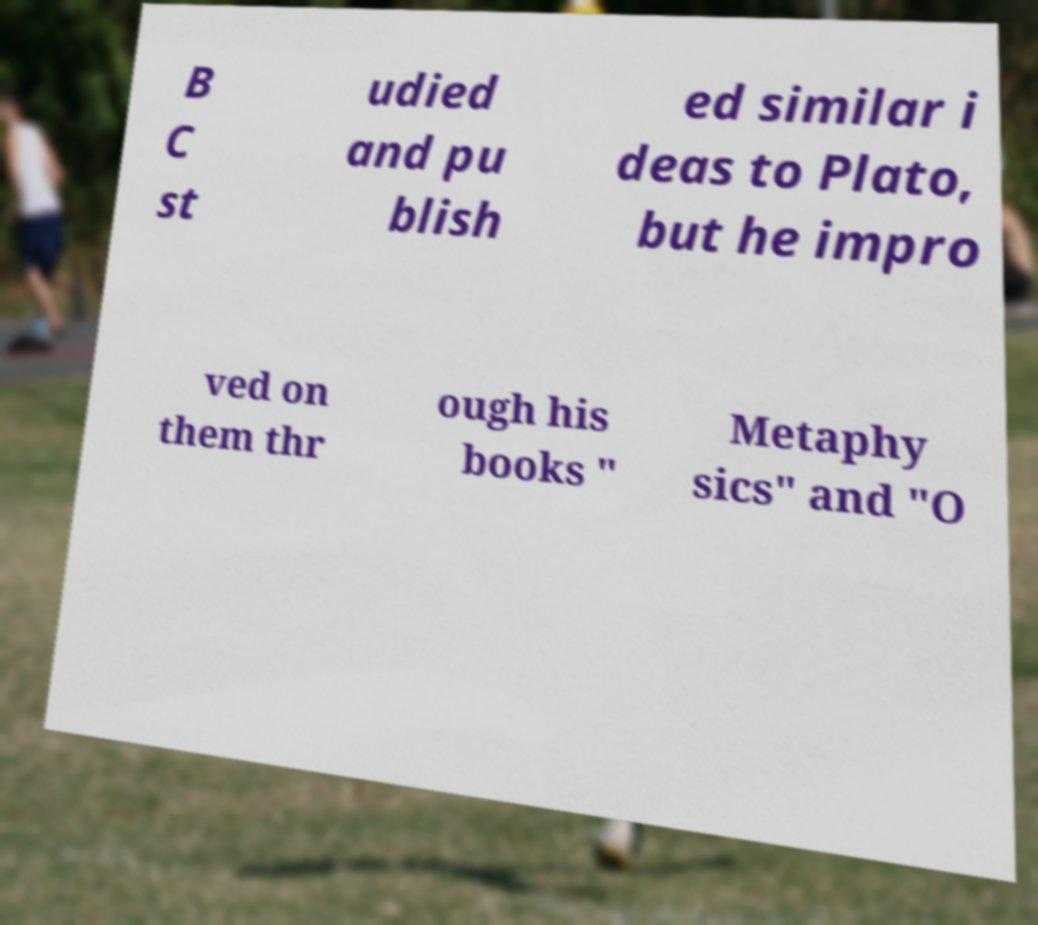Can you accurately transcribe the text from the provided image for me? B C st udied and pu blish ed similar i deas to Plato, but he impro ved on them thr ough his books " Metaphy sics" and "O 